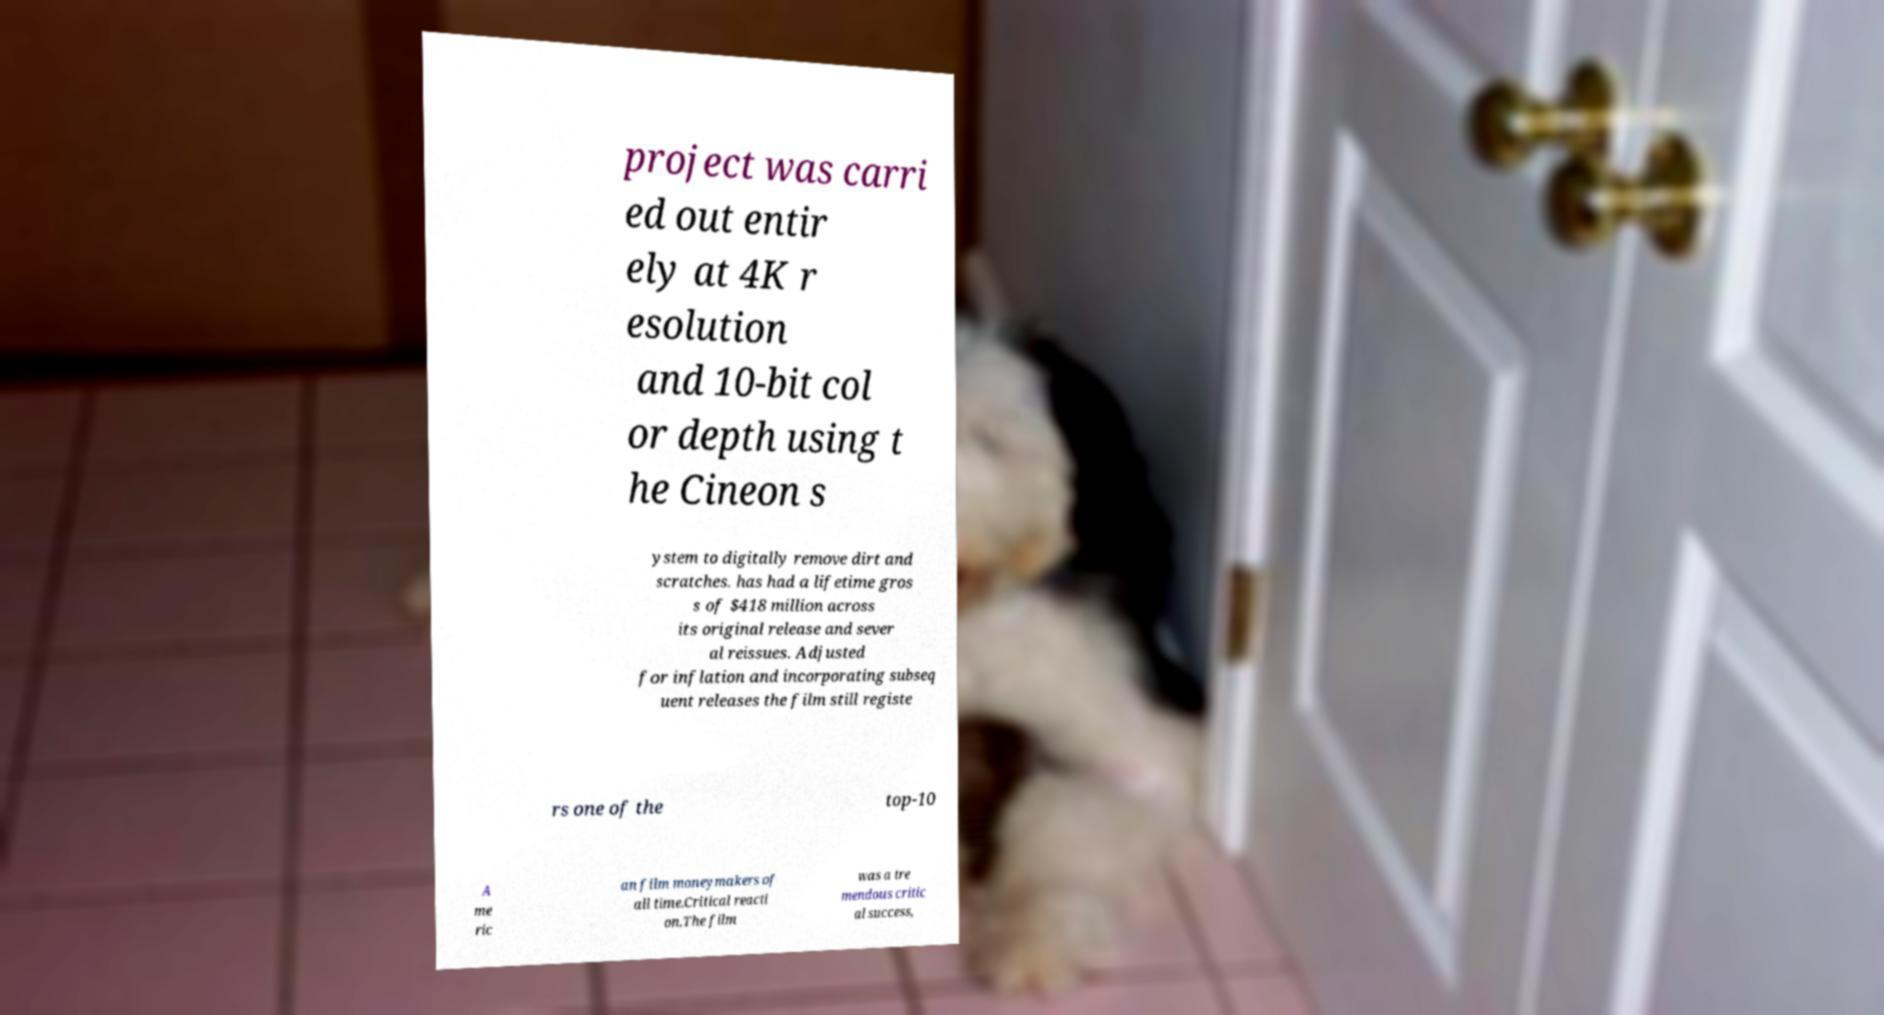What messages or text are displayed in this image? I need them in a readable, typed format. project was carri ed out entir ely at 4K r esolution and 10-bit col or depth using t he Cineon s ystem to digitally remove dirt and scratches. has had a lifetime gros s of $418 million across its original release and sever al reissues. Adjusted for inflation and incorporating subseq uent releases the film still registe rs one of the top-10 A me ric an film moneymakers of all time.Critical reacti on.The film was a tre mendous critic al success, 